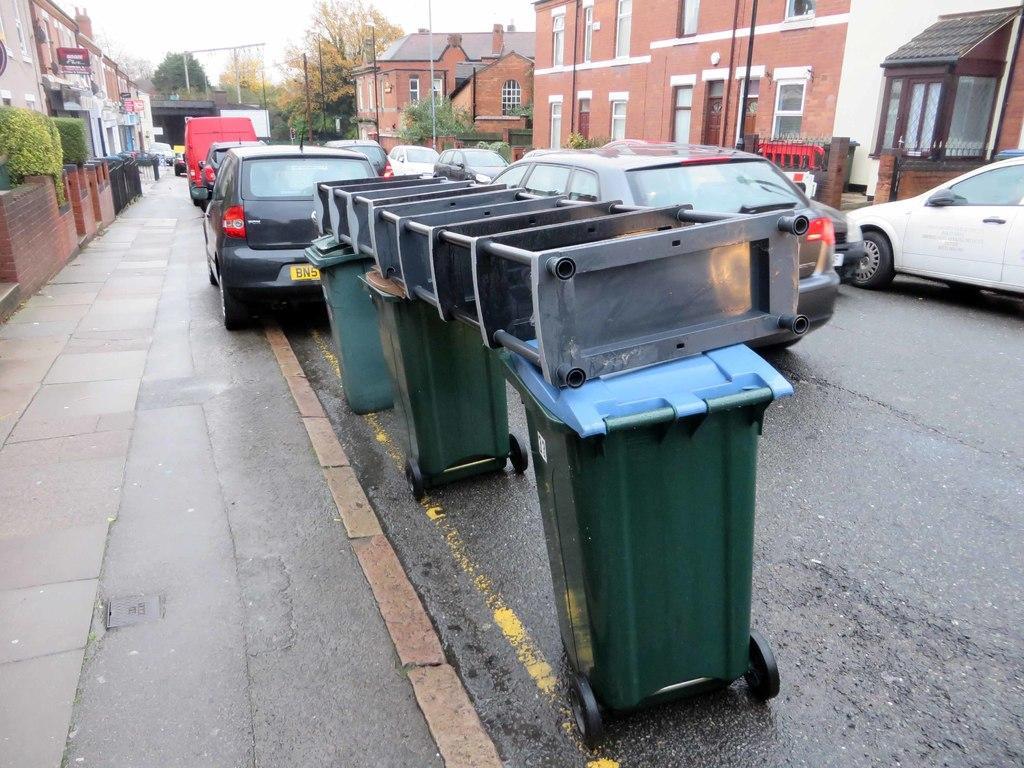Could you give a brief overview of what you see in this image? In this image I see number of buildings, bushes, cars and I see 3 bins over here on which there is a thing and I see the footpath and the road. In the background I see the trees, few poles and the sky. 